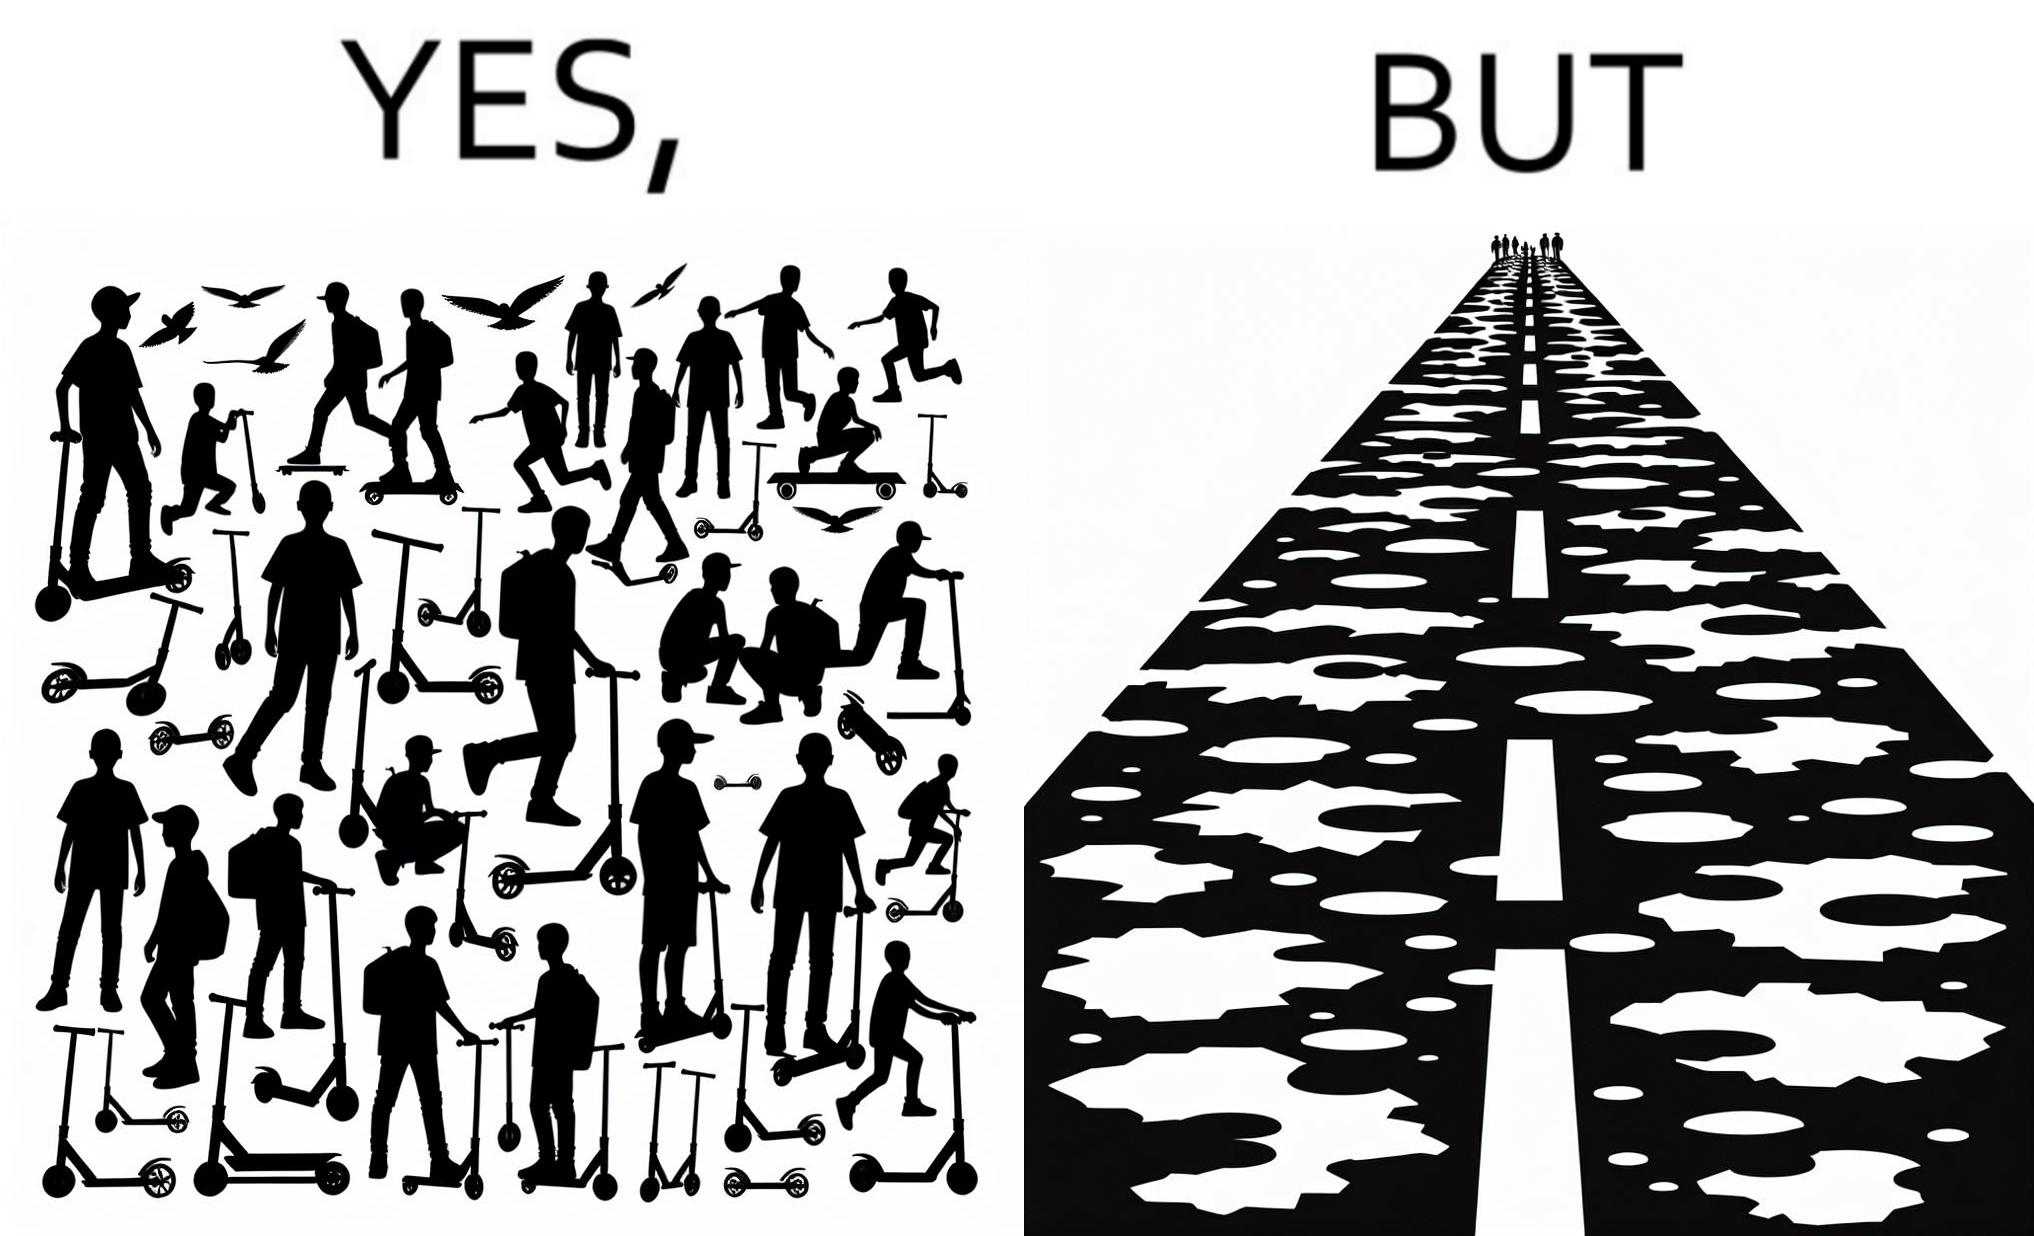Is this a satirical image? Yes, this image is satirical. 